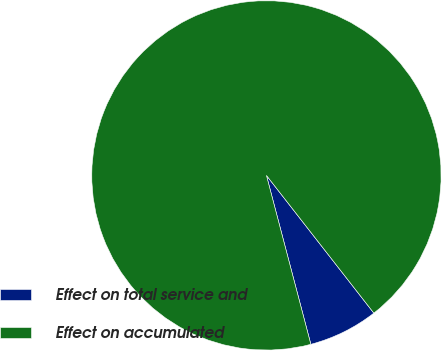<chart> <loc_0><loc_0><loc_500><loc_500><pie_chart><fcel>Effect on total service and<fcel>Effect on accumulated<nl><fcel>6.45%<fcel>93.55%<nl></chart> 